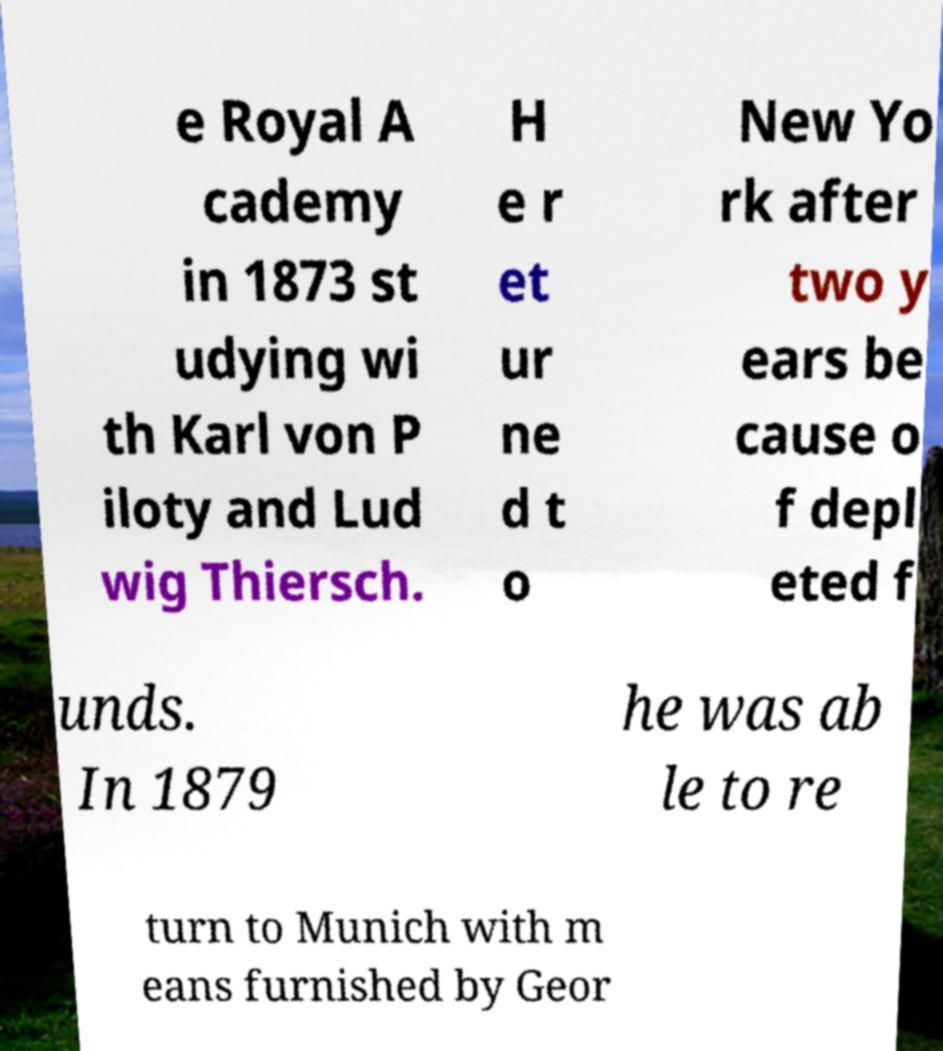Can you read and provide the text displayed in the image?This photo seems to have some interesting text. Can you extract and type it out for me? e Royal A cademy in 1873 st udying wi th Karl von P iloty and Lud wig Thiersch. H e r et ur ne d t o New Yo rk after two y ears be cause o f depl eted f unds. In 1879 he was ab le to re turn to Munich with m eans furnished by Geor 